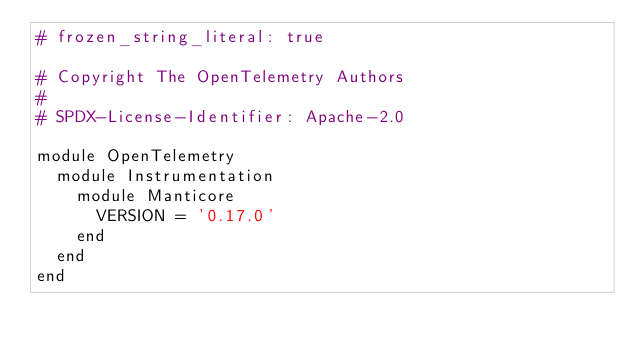<code> <loc_0><loc_0><loc_500><loc_500><_Ruby_># frozen_string_literal: true

# Copyright The OpenTelemetry Authors
#
# SPDX-License-Identifier: Apache-2.0

module OpenTelemetry
  module Instrumentation
    module Manticore
      VERSION = '0.17.0'
    end
  end
end
</code> 